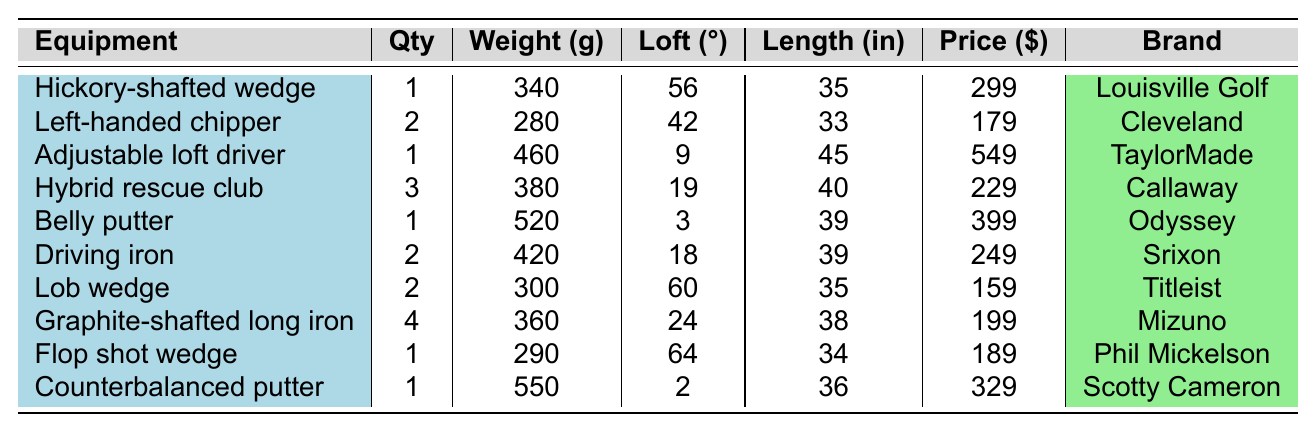What is the total quantity of golf equipment listed? To find the total quantity, sum all the quantities from each equipment type: 1 + 2 + 1 + 3 + 1 + 2 + 2 + 4 + 1 + 1 = 18
Answer: 18 Which equipment has the highest weight? The weights of all equipment are compared: 340, 280, 460, 380, 520, 420, 300, 360, 290, 550. The highest weight is 550 grams, corresponding to the Counterbalanced putter.
Answer: Counterbalanced putter How many equipment types have a loft greater than 20 degrees? Equipment with lofts are: 56, 42, 9, 19, 3, 18, 60, 24, 64, 2. The lofts greater than 20 degrees are 60, 24, and 64. Therefore, 3 types have lofts greater than 20 degrees.
Answer: 3 What is the average price of the equipment? First, sum all the prices: 299 + 179 + 549 + 229 + 399 + 249 + 159 + 199 + 189 + 329 = 2,125. Then divide by the number of equipment types (10): 2,125 / 10 = 212.5.
Answer: 212.5 Is there any equipment made of aluminum? Check the materials: Hickory, Steel, Titanium, Stainless Steel, Aluminum, Steel, Steel, Graphite, Steel, Steel. Aluminum is present, which confirms that there is equipment made of aluminum.
Answer: Yes What is the difference in weight between the lightest and heaviest equipment? The lightest equipment is the Left-handed chipper at 280 grams, and the heaviest is the Counterbalanced putter at 550 grams. The difference is 550 - 280 = 270 grams.
Answer: 270 grams Which brand has the most expensive equipment, and what is its price? The prices are checked: the Adjustable loft driver has the highest price at 549 USD, and it is a TaylorMade product.
Answer: TaylorMade, 549 What percentage of the total equipment quantity is represented by Graphite-shafted long iron? The Graphite-shafted long iron’s quantity is 4. To find the percentage, calculate (4 / 18) * 100 = 22.22%.
Answer: 22.22% Which equipment types are classified as "Wedge"? Look for the equipment with 'Wedge' in the flex category: Lob wedge and Flop shot wedge.
Answer: Lob wedge, Flop shot wedge How much heavier, on average, are the equipment types with a loft greater than 40 degrees compared to those 40 degrees or less? The equipment with lofts over 40 degrees are: Left-handed chipper (280g), Hybrid rescue club (380g), Belly putter (520g), Driving iron (420g), Lob wedge (300g), Graphite-shafted long iron (360g), Flop shot wedge (290g), and Counterbalanced putter (550g). Their average weight = (280 + 380 + 520 + 420 + 300 + 360 + 290 + 550) / 8 = 398.75g. For those with lofts ≤ 40 degrees: Hickory-shafted wedge (340g), Adjustable loft driver (460g). Average = (340 + 460) / 2 = 400g. The difference is 398.75 - 400 = -1.25g.
Answer: -1.25g 